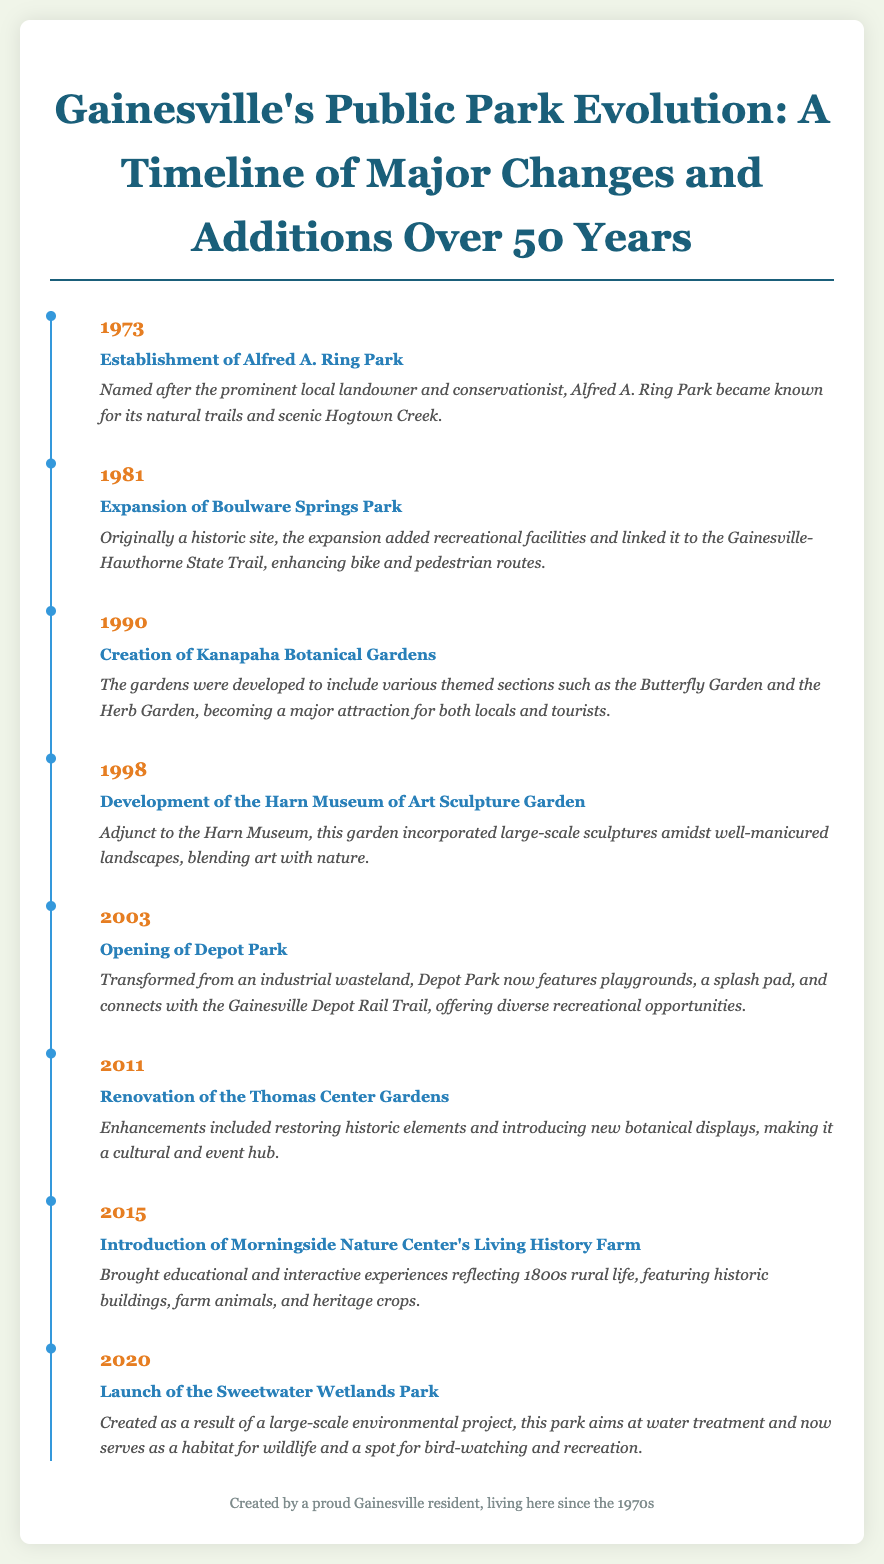What year was Alfred A. Ring Park established? Alfred A. Ring Park was established in 1973, as indicated in the timeline.
Answer: 1973 What significant feature was added to Boulware Springs Park in 1981? The expansion added recreational facilities and linked it to the Gainesville-Hawthorne State Trail.
Answer: Recreational facilities What type of gardens are included in the Kanapaha Botanical Gardens? The Kanapaha Botanical Gardens include various themed sections such as the Butterfly Garden and the Herb Garden.
Answer: Themed sections In what year did Depot Park open? Depot Park opened in 2003, according to the timeline provided.
Answer: 2003 What major addition was made to the Thomas Center Gardens in 2011? The renovations included restoring historic elements and introducing new botanical displays.
Answer: New botanical displays How did the Sweetwater Wetlands Park serve the community since its launch in 2020? The Sweetwater Wetlands Park aims at water treatment and serves as a habitat for wildlife and a spot for bird-watching and recreation.
Answer: Habitat for wildlife What is the primary focus of Morningside Nature Center's Living History Farm? The primary focus is to provide educational and interactive experiences reflecting 1800s rural life.
Answer: 1800s rural life Which park development incorporated large-scale sculptures amidst the landscape? The Harn Museum of Art Sculpture Garden incorporates large-scale sculptures amidst well-manicured landscapes.
Answer: Harn Museum of Art Sculpture Garden 